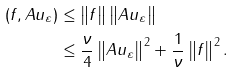Convert formula to latex. <formula><loc_0><loc_0><loc_500><loc_500>( f , A u _ { \varepsilon } ) & \leq \left \| f \right \| \left \| A u _ { \varepsilon } \right \| \\ & \leq \frac { \nu } { 4 } \left \| A u _ { \varepsilon } \right \| ^ { 2 } + \frac { 1 } { \nu } \left \| f \right \| ^ { 2 } .</formula> 